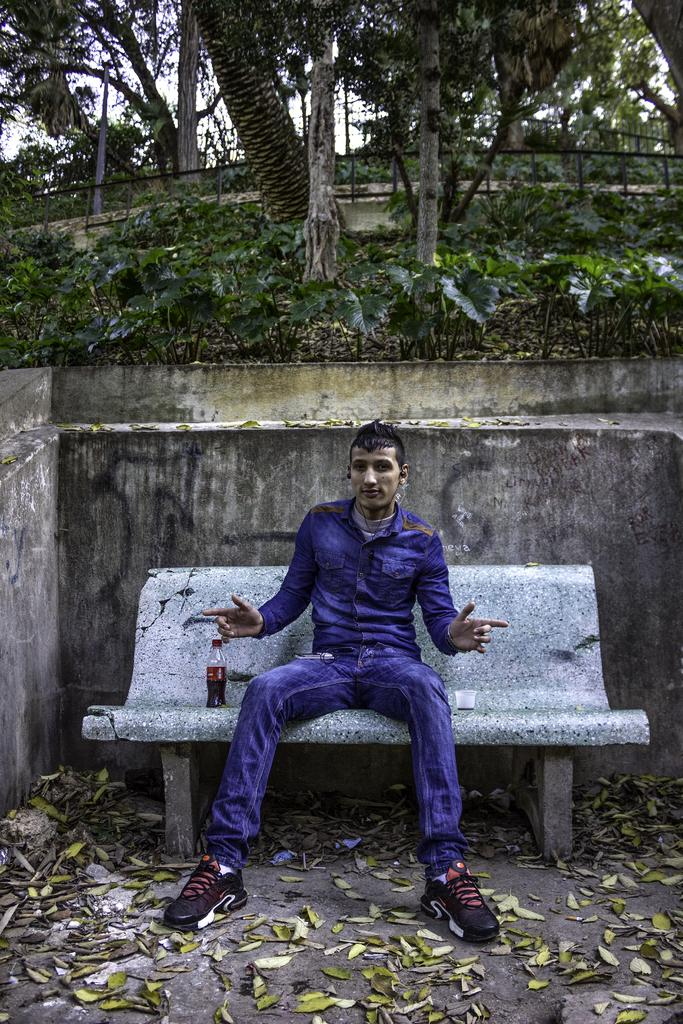What is the man in the image doing? The man is seated on a bench in the image. What object is beside the man? There is a bottle beside the man. What can be seen in the background of the image? Trees are visible in the background of the image. How does the man smash the trees in the background of the image? The man does not smash the trees in the image; he is seated on a bench, and the trees are in the background. 